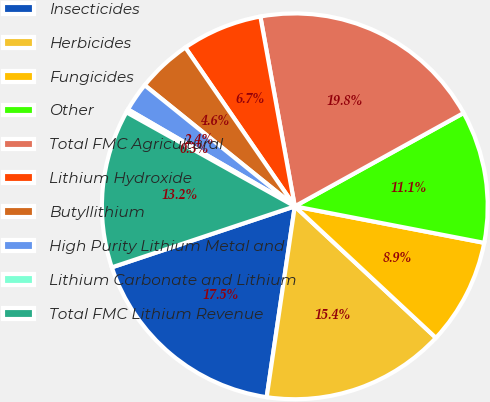<chart> <loc_0><loc_0><loc_500><loc_500><pie_chart><fcel>Insecticides<fcel>Herbicides<fcel>Fungicides<fcel>Other<fcel>Total FMC Agricultural<fcel>Lithium Hydroxide<fcel>Butyllithium<fcel>High Purity Lithium Metal and<fcel>Lithium Carbonate and Lithium<fcel>Total FMC Lithium Revenue<nl><fcel>17.55%<fcel>15.39%<fcel>8.91%<fcel>11.07%<fcel>19.82%<fcel>6.75%<fcel>4.59%<fcel>2.43%<fcel>0.27%<fcel>13.23%<nl></chart> 